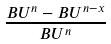<formula> <loc_0><loc_0><loc_500><loc_500>\frac { B U ^ { n } - B U ^ { n - x } } { B U ^ { n } }</formula> 